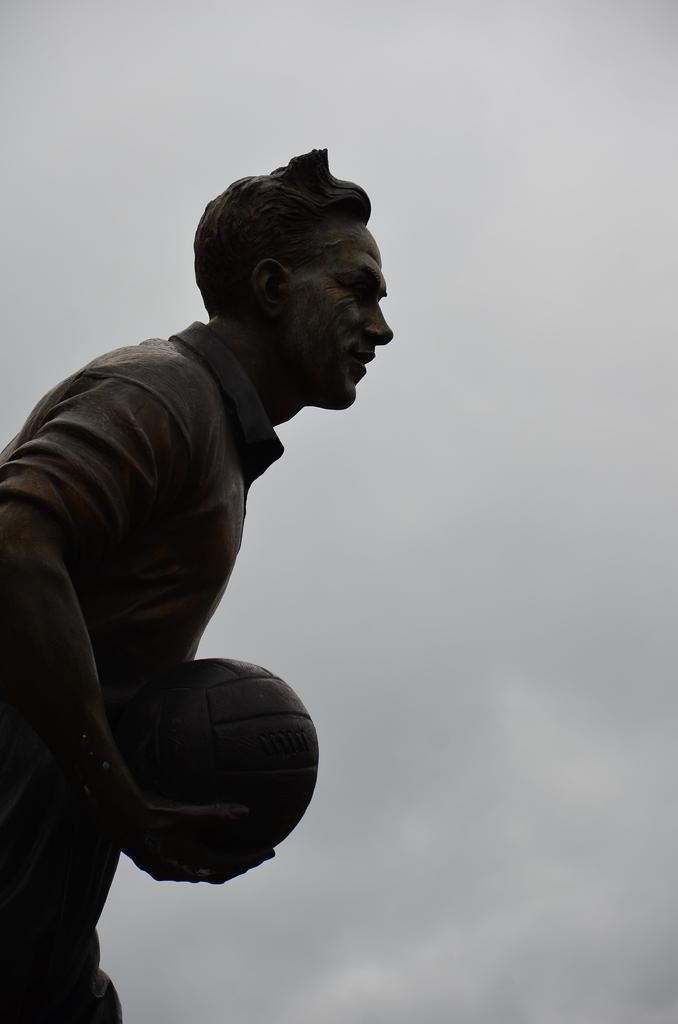Describe this image in one or two sentences. In this image I can see a sculpture of a man holding a ball. 